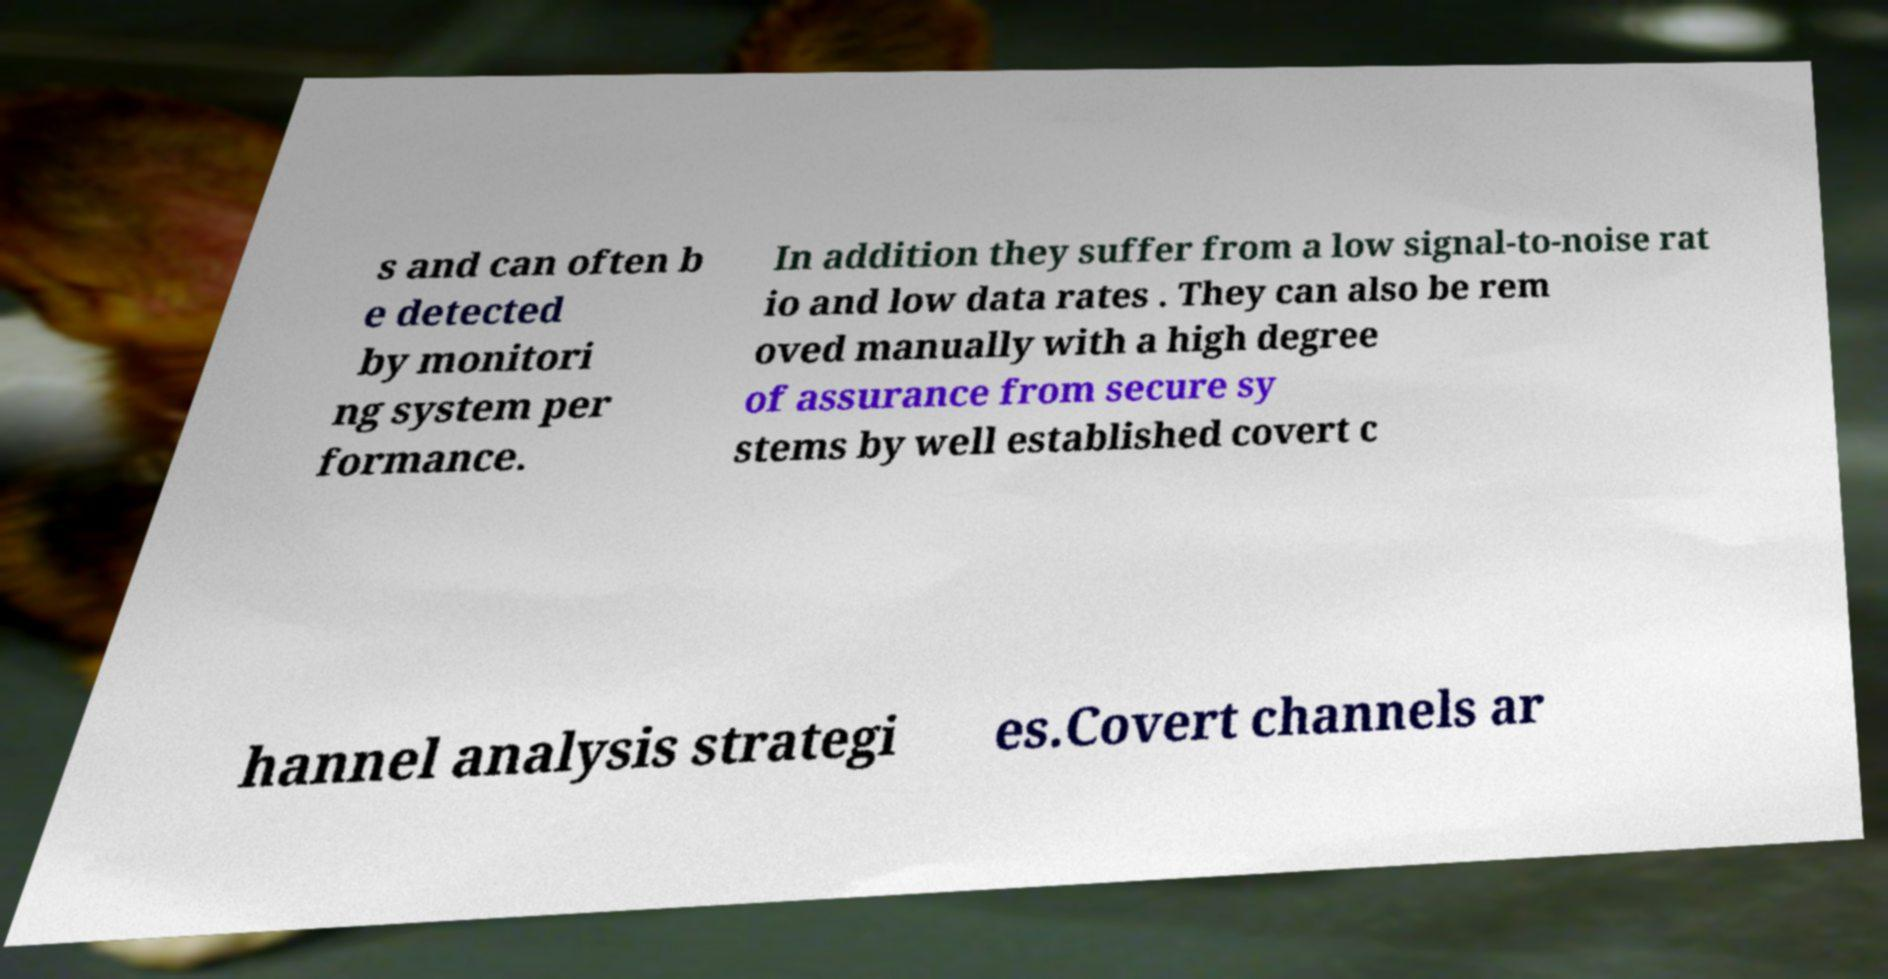Please identify and transcribe the text found in this image. s and can often b e detected by monitori ng system per formance. In addition they suffer from a low signal-to-noise rat io and low data rates . They can also be rem oved manually with a high degree of assurance from secure sy stems by well established covert c hannel analysis strategi es.Covert channels ar 